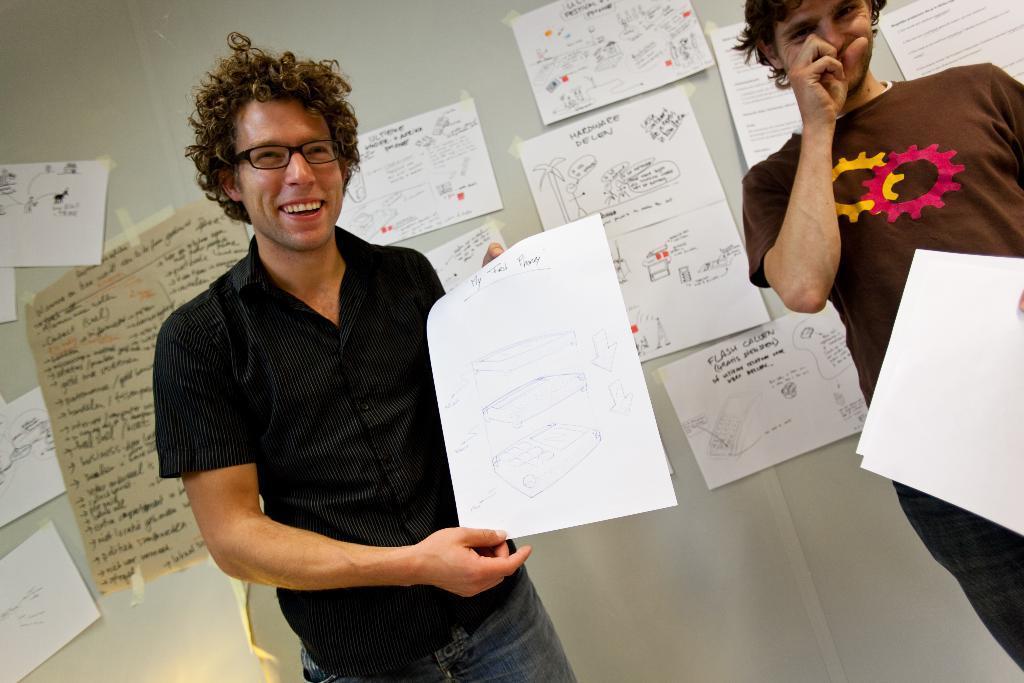In one or two sentences, can you explain what this image depicts? In this picture I can see there are two men standing and the person at right is holding a paper and there is a person at left he is smiling and holding few more papers. In the backdrop there are few more papers on the wall. 